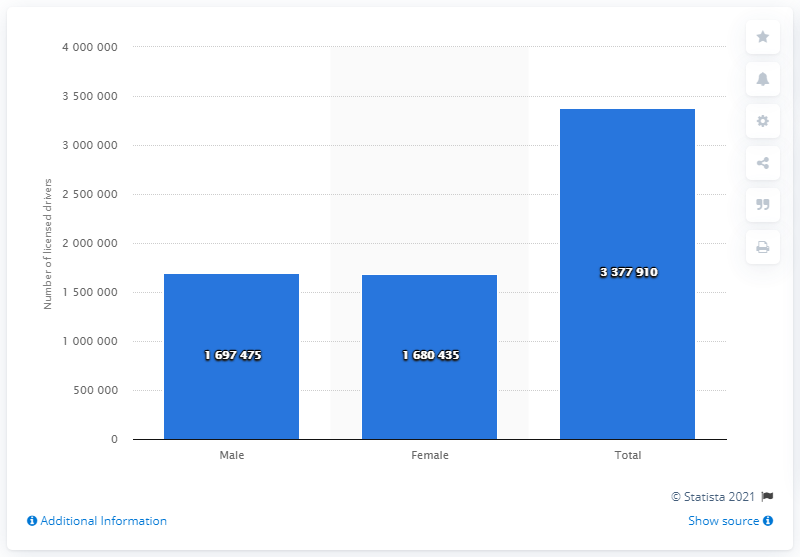Point out several critical features in this image. In 2016, there were 1,680,435 female drivers on the roads in the state of Minnesota. 